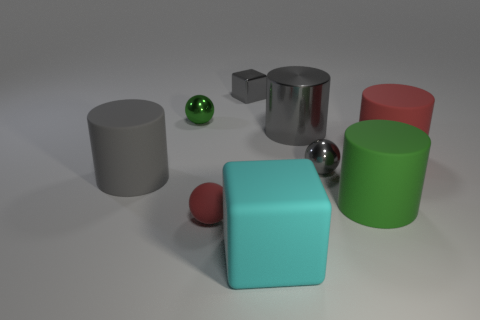Subtract 1 cylinders. How many cylinders are left? 3 Subtract all cyan cylinders. Subtract all red spheres. How many cylinders are left? 4 Subtract all cylinders. How many objects are left? 5 Subtract all big gray matte cylinders. Subtract all cyan objects. How many objects are left? 7 Add 1 tiny red things. How many tiny red things are left? 2 Add 9 large green rubber cubes. How many large green rubber cubes exist? 9 Subtract 0 cyan cylinders. How many objects are left? 9 